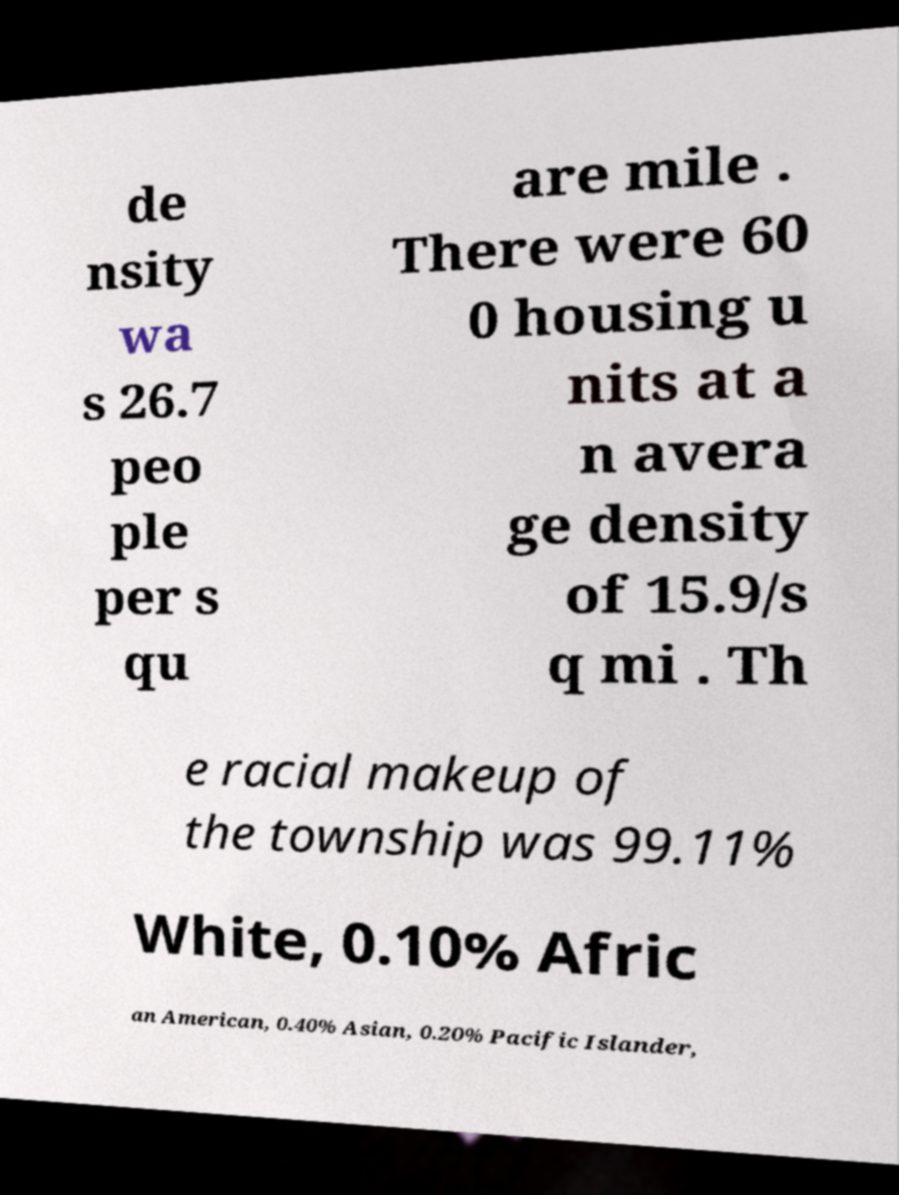Could you assist in decoding the text presented in this image and type it out clearly? de nsity wa s 26.7 peo ple per s qu are mile . There were 60 0 housing u nits at a n avera ge density of 15.9/s q mi . Th e racial makeup of the township was 99.11% White, 0.10% Afric an American, 0.40% Asian, 0.20% Pacific Islander, 